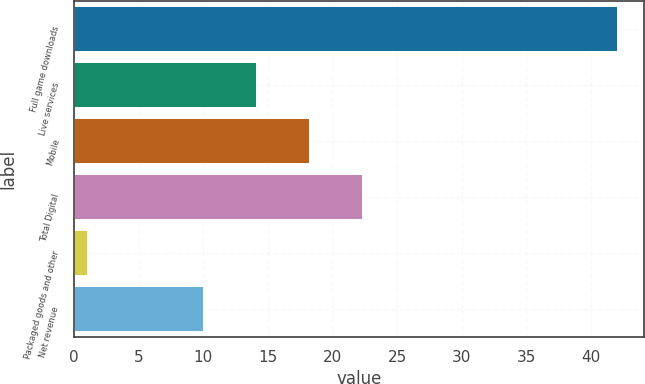<chart> <loc_0><loc_0><loc_500><loc_500><bar_chart><fcel>Full game downloads<fcel>Live services<fcel>Mobile<fcel>Total Digital<fcel>Packaged goods and other<fcel>Net revenue<nl><fcel>42<fcel>14.1<fcel>18.2<fcel>22.3<fcel>1<fcel>10<nl></chart> 